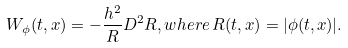Convert formula to latex. <formula><loc_0><loc_0><loc_500><loc_500>W _ { \phi } ( t , x ) = - \frac { h ^ { 2 } } { R } D ^ { 2 } R , w h e r e \, R ( t , x ) = | \phi ( t , x ) | .</formula> 